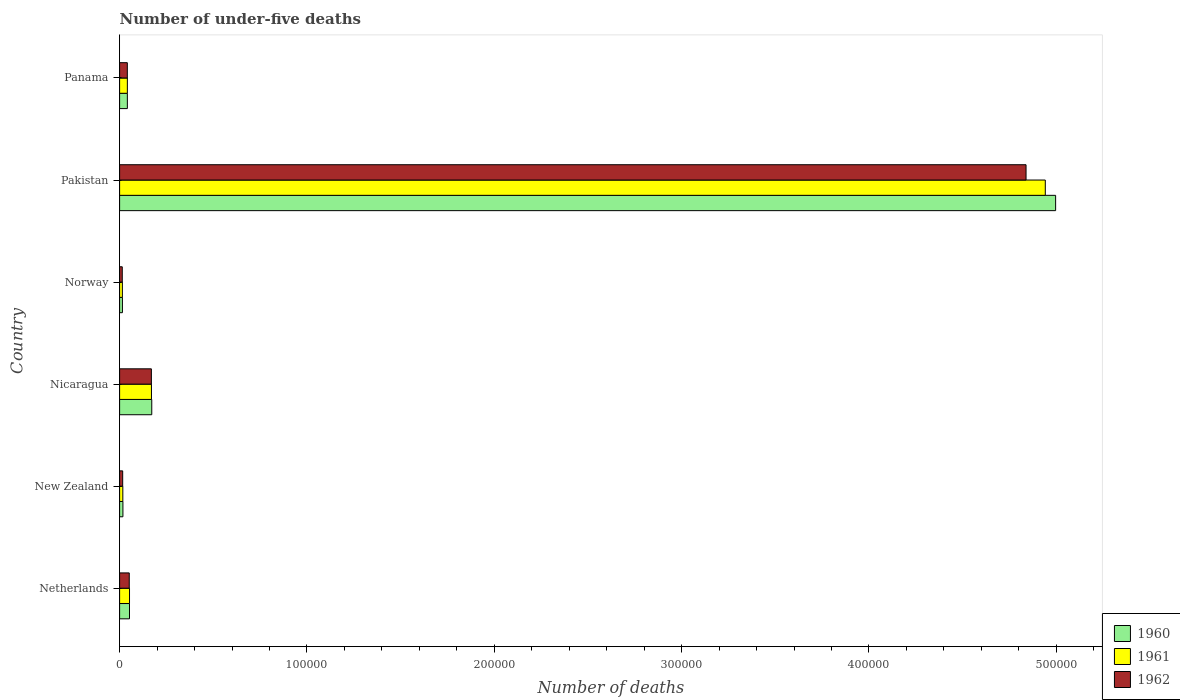Are the number of bars per tick equal to the number of legend labels?
Ensure brevity in your answer.  Yes. Are the number of bars on each tick of the Y-axis equal?
Provide a succinct answer. Yes. How many bars are there on the 2nd tick from the top?
Give a very brief answer. 3. How many bars are there on the 4th tick from the bottom?
Offer a very short reply. 3. In how many cases, is the number of bars for a given country not equal to the number of legend labels?
Make the answer very short. 0. What is the number of under-five deaths in 1962 in New Zealand?
Your answer should be very brief. 1649. Across all countries, what is the maximum number of under-five deaths in 1962?
Keep it short and to the point. 4.84e+05. Across all countries, what is the minimum number of under-five deaths in 1961?
Offer a very short reply. 1480. In which country was the number of under-five deaths in 1960 maximum?
Your answer should be very brief. Pakistan. What is the total number of under-five deaths in 1962 in the graph?
Make the answer very short. 5.13e+05. What is the difference between the number of under-five deaths in 1960 in Netherlands and that in Norway?
Offer a very short reply. 3778. What is the difference between the number of under-five deaths in 1961 in Netherlands and the number of under-five deaths in 1962 in Norway?
Keep it short and to the point. 3866. What is the average number of under-five deaths in 1962 per country?
Give a very brief answer. 8.55e+04. In how many countries, is the number of under-five deaths in 1960 greater than 300000 ?
Keep it short and to the point. 1. What is the ratio of the number of under-five deaths in 1961 in Netherlands to that in Pakistan?
Offer a terse response. 0.01. Is the number of under-five deaths in 1960 in New Zealand less than that in Panama?
Your answer should be compact. Yes. Is the difference between the number of under-five deaths in 1960 in Netherlands and New Zealand greater than the difference between the number of under-five deaths in 1961 in Netherlands and New Zealand?
Offer a terse response. No. What is the difference between the highest and the second highest number of under-five deaths in 1961?
Your answer should be very brief. 4.77e+05. What is the difference between the highest and the lowest number of under-five deaths in 1960?
Your answer should be very brief. 4.98e+05. Is it the case that in every country, the sum of the number of under-five deaths in 1961 and number of under-five deaths in 1962 is greater than the number of under-five deaths in 1960?
Offer a terse response. Yes. How many countries are there in the graph?
Keep it short and to the point. 6. Does the graph contain grids?
Your response must be concise. No. Where does the legend appear in the graph?
Your answer should be very brief. Bottom right. How many legend labels are there?
Offer a terse response. 3. How are the legend labels stacked?
Give a very brief answer. Vertical. What is the title of the graph?
Your answer should be very brief. Number of under-five deaths. What is the label or title of the X-axis?
Ensure brevity in your answer.  Number of deaths. What is the Number of deaths in 1960 in Netherlands?
Provide a succinct answer. 5281. What is the Number of deaths in 1961 in Netherlands?
Your response must be concise. 5288. What is the Number of deaths of 1962 in Netherlands?
Your response must be concise. 5152. What is the Number of deaths in 1960 in New Zealand?
Ensure brevity in your answer.  1768. What is the Number of deaths in 1961 in New Zealand?
Offer a very short reply. 1719. What is the Number of deaths in 1962 in New Zealand?
Provide a short and direct response. 1649. What is the Number of deaths of 1960 in Nicaragua?
Ensure brevity in your answer.  1.72e+04. What is the Number of deaths of 1961 in Nicaragua?
Keep it short and to the point. 1.70e+04. What is the Number of deaths of 1962 in Nicaragua?
Your response must be concise. 1.70e+04. What is the Number of deaths in 1960 in Norway?
Offer a terse response. 1503. What is the Number of deaths in 1961 in Norway?
Give a very brief answer. 1480. What is the Number of deaths in 1962 in Norway?
Make the answer very short. 1422. What is the Number of deaths of 1960 in Pakistan?
Provide a short and direct response. 5.00e+05. What is the Number of deaths in 1961 in Pakistan?
Your response must be concise. 4.94e+05. What is the Number of deaths in 1962 in Pakistan?
Give a very brief answer. 4.84e+05. What is the Number of deaths of 1960 in Panama?
Offer a terse response. 4142. What is the Number of deaths of 1961 in Panama?
Offer a very short reply. 4139. What is the Number of deaths in 1962 in Panama?
Your answer should be very brief. 4122. Across all countries, what is the maximum Number of deaths in 1960?
Provide a succinct answer. 5.00e+05. Across all countries, what is the maximum Number of deaths in 1961?
Ensure brevity in your answer.  4.94e+05. Across all countries, what is the maximum Number of deaths of 1962?
Ensure brevity in your answer.  4.84e+05. Across all countries, what is the minimum Number of deaths of 1960?
Your answer should be compact. 1503. Across all countries, what is the minimum Number of deaths of 1961?
Your response must be concise. 1480. Across all countries, what is the minimum Number of deaths of 1962?
Ensure brevity in your answer.  1422. What is the total Number of deaths in 1960 in the graph?
Your response must be concise. 5.30e+05. What is the total Number of deaths of 1961 in the graph?
Your answer should be very brief. 5.24e+05. What is the total Number of deaths of 1962 in the graph?
Ensure brevity in your answer.  5.13e+05. What is the difference between the Number of deaths in 1960 in Netherlands and that in New Zealand?
Ensure brevity in your answer.  3513. What is the difference between the Number of deaths in 1961 in Netherlands and that in New Zealand?
Offer a terse response. 3569. What is the difference between the Number of deaths of 1962 in Netherlands and that in New Zealand?
Provide a short and direct response. 3503. What is the difference between the Number of deaths of 1960 in Netherlands and that in Nicaragua?
Offer a very short reply. -1.19e+04. What is the difference between the Number of deaths in 1961 in Netherlands and that in Nicaragua?
Offer a terse response. -1.17e+04. What is the difference between the Number of deaths in 1962 in Netherlands and that in Nicaragua?
Offer a very short reply. -1.18e+04. What is the difference between the Number of deaths of 1960 in Netherlands and that in Norway?
Your answer should be compact. 3778. What is the difference between the Number of deaths of 1961 in Netherlands and that in Norway?
Make the answer very short. 3808. What is the difference between the Number of deaths of 1962 in Netherlands and that in Norway?
Provide a short and direct response. 3730. What is the difference between the Number of deaths of 1960 in Netherlands and that in Pakistan?
Ensure brevity in your answer.  -4.94e+05. What is the difference between the Number of deaths of 1961 in Netherlands and that in Pakistan?
Give a very brief answer. -4.89e+05. What is the difference between the Number of deaths of 1962 in Netherlands and that in Pakistan?
Your answer should be very brief. -4.79e+05. What is the difference between the Number of deaths of 1960 in Netherlands and that in Panama?
Ensure brevity in your answer.  1139. What is the difference between the Number of deaths in 1961 in Netherlands and that in Panama?
Your answer should be very brief. 1149. What is the difference between the Number of deaths in 1962 in Netherlands and that in Panama?
Offer a very short reply. 1030. What is the difference between the Number of deaths in 1960 in New Zealand and that in Nicaragua?
Provide a succinct answer. -1.54e+04. What is the difference between the Number of deaths of 1961 in New Zealand and that in Nicaragua?
Your answer should be compact. -1.53e+04. What is the difference between the Number of deaths in 1962 in New Zealand and that in Nicaragua?
Provide a succinct answer. -1.53e+04. What is the difference between the Number of deaths in 1960 in New Zealand and that in Norway?
Provide a short and direct response. 265. What is the difference between the Number of deaths of 1961 in New Zealand and that in Norway?
Ensure brevity in your answer.  239. What is the difference between the Number of deaths in 1962 in New Zealand and that in Norway?
Give a very brief answer. 227. What is the difference between the Number of deaths of 1960 in New Zealand and that in Pakistan?
Offer a very short reply. -4.98e+05. What is the difference between the Number of deaths in 1961 in New Zealand and that in Pakistan?
Offer a very short reply. -4.92e+05. What is the difference between the Number of deaths of 1962 in New Zealand and that in Pakistan?
Your answer should be compact. -4.82e+05. What is the difference between the Number of deaths of 1960 in New Zealand and that in Panama?
Offer a very short reply. -2374. What is the difference between the Number of deaths of 1961 in New Zealand and that in Panama?
Provide a succinct answer. -2420. What is the difference between the Number of deaths of 1962 in New Zealand and that in Panama?
Offer a terse response. -2473. What is the difference between the Number of deaths in 1960 in Nicaragua and that in Norway?
Give a very brief answer. 1.57e+04. What is the difference between the Number of deaths in 1961 in Nicaragua and that in Norway?
Make the answer very short. 1.55e+04. What is the difference between the Number of deaths of 1962 in Nicaragua and that in Norway?
Make the answer very short. 1.55e+04. What is the difference between the Number of deaths of 1960 in Nicaragua and that in Pakistan?
Your response must be concise. -4.82e+05. What is the difference between the Number of deaths in 1961 in Nicaragua and that in Pakistan?
Your answer should be compact. -4.77e+05. What is the difference between the Number of deaths in 1962 in Nicaragua and that in Pakistan?
Your response must be concise. -4.67e+05. What is the difference between the Number of deaths in 1960 in Nicaragua and that in Panama?
Your answer should be compact. 1.30e+04. What is the difference between the Number of deaths in 1961 in Nicaragua and that in Panama?
Make the answer very short. 1.29e+04. What is the difference between the Number of deaths in 1962 in Nicaragua and that in Panama?
Make the answer very short. 1.28e+04. What is the difference between the Number of deaths of 1960 in Norway and that in Pakistan?
Provide a short and direct response. -4.98e+05. What is the difference between the Number of deaths in 1961 in Norway and that in Pakistan?
Your answer should be compact. -4.93e+05. What is the difference between the Number of deaths of 1962 in Norway and that in Pakistan?
Your answer should be very brief. -4.82e+05. What is the difference between the Number of deaths of 1960 in Norway and that in Panama?
Offer a very short reply. -2639. What is the difference between the Number of deaths in 1961 in Norway and that in Panama?
Offer a very short reply. -2659. What is the difference between the Number of deaths of 1962 in Norway and that in Panama?
Make the answer very short. -2700. What is the difference between the Number of deaths of 1960 in Pakistan and that in Panama?
Make the answer very short. 4.96e+05. What is the difference between the Number of deaths in 1961 in Pakistan and that in Panama?
Your answer should be compact. 4.90e+05. What is the difference between the Number of deaths in 1962 in Pakistan and that in Panama?
Give a very brief answer. 4.80e+05. What is the difference between the Number of deaths in 1960 in Netherlands and the Number of deaths in 1961 in New Zealand?
Your answer should be very brief. 3562. What is the difference between the Number of deaths in 1960 in Netherlands and the Number of deaths in 1962 in New Zealand?
Your response must be concise. 3632. What is the difference between the Number of deaths of 1961 in Netherlands and the Number of deaths of 1962 in New Zealand?
Give a very brief answer. 3639. What is the difference between the Number of deaths in 1960 in Netherlands and the Number of deaths in 1961 in Nicaragua?
Give a very brief answer. -1.17e+04. What is the difference between the Number of deaths in 1960 in Netherlands and the Number of deaths in 1962 in Nicaragua?
Provide a short and direct response. -1.17e+04. What is the difference between the Number of deaths in 1961 in Netherlands and the Number of deaths in 1962 in Nicaragua?
Offer a terse response. -1.17e+04. What is the difference between the Number of deaths in 1960 in Netherlands and the Number of deaths in 1961 in Norway?
Your response must be concise. 3801. What is the difference between the Number of deaths of 1960 in Netherlands and the Number of deaths of 1962 in Norway?
Keep it short and to the point. 3859. What is the difference between the Number of deaths in 1961 in Netherlands and the Number of deaths in 1962 in Norway?
Provide a succinct answer. 3866. What is the difference between the Number of deaths of 1960 in Netherlands and the Number of deaths of 1961 in Pakistan?
Your answer should be compact. -4.89e+05. What is the difference between the Number of deaths of 1960 in Netherlands and the Number of deaths of 1962 in Pakistan?
Keep it short and to the point. -4.79e+05. What is the difference between the Number of deaths in 1961 in Netherlands and the Number of deaths in 1962 in Pakistan?
Your answer should be compact. -4.79e+05. What is the difference between the Number of deaths of 1960 in Netherlands and the Number of deaths of 1961 in Panama?
Provide a short and direct response. 1142. What is the difference between the Number of deaths of 1960 in Netherlands and the Number of deaths of 1962 in Panama?
Keep it short and to the point. 1159. What is the difference between the Number of deaths in 1961 in Netherlands and the Number of deaths in 1962 in Panama?
Offer a very short reply. 1166. What is the difference between the Number of deaths of 1960 in New Zealand and the Number of deaths of 1961 in Nicaragua?
Keep it short and to the point. -1.52e+04. What is the difference between the Number of deaths of 1960 in New Zealand and the Number of deaths of 1962 in Nicaragua?
Provide a succinct answer. -1.52e+04. What is the difference between the Number of deaths in 1961 in New Zealand and the Number of deaths in 1962 in Nicaragua?
Your answer should be compact. -1.52e+04. What is the difference between the Number of deaths of 1960 in New Zealand and the Number of deaths of 1961 in Norway?
Provide a succinct answer. 288. What is the difference between the Number of deaths of 1960 in New Zealand and the Number of deaths of 1962 in Norway?
Your answer should be very brief. 346. What is the difference between the Number of deaths in 1961 in New Zealand and the Number of deaths in 1962 in Norway?
Give a very brief answer. 297. What is the difference between the Number of deaths of 1960 in New Zealand and the Number of deaths of 1961 in Pakistan?
Your response must be concise. -4.92e+05. What is the difference between the Number of deaths of 1960 in New Zealand and the Number of deaths of 1962 in Pakistan?
Make the answer very short. -4.82e+05. What is the difference between the Number of deaths in 1961 in New Zealand and the Number of deaths in 1962 in Pakistan?
Keep it short and to the point. -4.82e+05. What is the difference between the Number of deaths in 1960 in New Zealand and the Number of deaths in 1961 in Panama?
Offer a terse response. -2371. What is the difference between the Number of deaths in 1960 in New Zealand and the Number of deaths in 1962 in Panama?
Make the answer very short. -2354. What is the difference between the Number of deaths of 1961 in New Zealand and the Number of deaths of 1962 in Panama?
Provide a short and direct response. -2403. What is the difference between the Number of deaths in 1960 in Nicaragua and the Number of deaths in 1961 in Norway?
Your answer should be compact. 1.57e+04. What is the difference between the Number of deaths in 1960 in Nicaragua and the Number of deaths in 1962 in Norway?
Offer a very short reply. 1.57e+04. What is the difference between the Number of deaths in 1961 in Nicaragua and the Number of deaths in 1962 in Norway?
Your answer should be very brief. 1.56e+04. What is the difference between the Number of deaths of 1960 in Nicaragua and the Number of deaths of 1961 in Pakistan?
Make the answer very short. -4.77e+05. What is the difference between the Number of deaths in 1960 in Nicaragua and the Number of deaths in 1962 in Pakistan?
Your answer should be very brief. -4.67e+05. What is the difference between the Number of deaths of 1961 in Nicaragua and the Number of deaths of 1962 in Pakistan?
Offer a very short reply. -4.67e+05. What is the difference between the Number of deaths in 1960 in Nicaragua and the Number of deaths in 1961 in Panama?
Your answer should be very brief. 1.30e+04. What is the difference between the Number of deaths in 1960 in Nicaragua and the Number of deaths in 1962 in Panama?
Provide a short and direct response. 1.30e+04. What is the difference between the Number of deaths of 1961 in Nicaragua and the Number of deaths of 1962 in Panama?
Give a very brief answer. 1.29e+04. What is the difference between the Number of deaths in 1960 in Norway and the Number of deaths in 1961 in Pakistan?
Offer a terse response. -4.93e+05. What is the difference between the Number of deaths of 1960 in Norway and the Number of deaths of 1962 in Pakistan?
Your response must be concise. -4.82e+05. What is the difference between the Number of deaths of 1961 in Norway and the Number of deaths of 1962 in Pakistan?
Provide a succinct answer. -4.82e+05. What is the difference between the Number of deaths in 1960 in Norway and the Number of deaths in 1961 in Panama?
Offer a very short reply. -2636. What is the difference between the Number of deaths of 1960 in Norway and the Number of deaths of 1962 in Panama?
Give a very brief answer. -2619. What is the difference between the Number of deaths of 1961 in Norway and the Number of deaths of 1962 in Panama?
Offer a very short reply. -2642. What is the difference between the Number of deaths in 1960 in Pakistan and the Number of deaths in 1961 in Panama?
Offer a terse response. 4.96e+05. What is the difference between the Number of deaths of 1960 in Pakistan and the Number of deaths of 1962 in Panama?
Make the answer very short. 4.96e+05. What is the difference between the Number of deaths of 1961 in Pakistan and the Number of deaths of 1962 in Panama?
Ensure brevity in your answer.  4.90e+05. What is the average Number of deaths of 1960 per country?
Keep it short and to the point. 8.83e+04. What is the average Number of deaths of 1961 per country?
Provide a short and direct response. 8.73e+04. What is the average Number of deaths in 1962 per country?
Keep it short and to the point. 8.55e+04. What is the difference between the Number of deaths in 1960 and Number of deaths in 1961 in Netherlands?
Provide a short and direct response. -7. What is the difference between the Number of deaths of 1960 and Number of deaths of 1962 in Netherlands?
Your answer should be very brief. 129. What is the difference between the Number of deaths of 1961 and Number of deaths of 1962 in Netherlands?
Make the answer very short. 136. What is the difference between the Number of deaths in 1960 and Number of deaths in 1961 in New Zealand?
Your answer should be compact. 49. What is the difference between the Number of deaths in 1960 and Number of deaths in 1962 in New Zealand?
Give a very brief answer. 119. What is the difference between the Number of deaths in 1961 and Number of deaths in 1962 in New Zealand?
Offer a terse response. 70. What is the difference between the Number of deaths in 1960 and Number of deaths in 1961 in Nicaragua?
Your response must be concise. 167. What is the difference between the Number of deaths of 1960 and Number of deaths of 1962 in Nicaragua?
Offer a terse response. 207. What is the difference between the Number of deaths in 1961 and Number of deaths in 1962 in Nicaragua?
Offer a terse response. 40. What is the difference between the Number of deaths in 1960 and Number of deaths in 1961 in Norway?
Your response must be concise. 23. What is the difference between the Number of deaths in 1960 and Number of deaths in 1961 in Pakistan?
Offer a terse response. 5515. What is the difference between the Number of deaths in 1960 and Number of deaths in 1962 in Pakistan?
Provide a short and direct response. 1.58e+04. What is the difference between the Number of deaths in 1961 and Number of deaths in 1962 in Pakistan?
Ensure brevity in your answer.  1.03e+04. What is the difference between the Number of deaths in 1961 and Number of deaths in 1962 in Panama?
Provide a succinct answer. 17. What is the ratio of the Number of deaths of 1960 in Netherlands to that in New Zealand?
Your answer should be compact. 2.99. What is the ratio of the Number of deaths in 1961 in Netherlands to that in New Zealand?
Your answer should be very brief. 3.08. What is the ratio of the Number of deaths of 1962 in Netherlands to that in New Zealand?
Your answer should be very brief. 3.12. What is the ratio of the Number of deaths in 1960 in Netherlands to that in Nicaragua?
Your answer should be compact. 0.31. What is the ratio of the Number of deaths of 1961 in Netherlands to that in Nicaragua?
Give a very brief answer. 0.31. What is the ratio of the Number of deaths in 1962 in Netherlands to that in Nicaragua?
Give a very brief answer. 0.3. What is the ratio of the Number of deaths of 1960 in Netherlands to that in Norway?
Ensure brevity in your answer.  3.51. What is the ratio of the Number of deaths of 1961 in Netherlands to that in Norway?
Your answer should be compact. 3.57. What is the ratio of the Number of deaths of 1962 in Netherlands to that in Norway?
Offer a terse response. 3.62. What is the ratio of the Number of deaths in 1960 in Netherlands to that in Pakistan?
Keep it short and to the point. 0.01. What is the ratio of the Number of deaths of 1961 in Netherlands to that in Pakistan?
Your response must be concise. 0.01. What is the ratio of the Number of deaths in 1962 in Netherlands to that in Pakistan?
Your response must be concise. 0.01. What is the ratio of the Number of deaths of 1960 in Netherlands to that in Panama?
Your response must be concise. 1.27. What is the ratio of the Number of deaths of 1961 in Netherlands to that in Panama?
Make the answer very short. 1.28. What is the ratio of the Number of deaths in 1962 in Netherlands to that in Panama?
Offer a terse response. 1.25. What is the ratio of the Number of deaths in 1960 in New Zealand to that in Nicaragua?
Offer a very short reply. 0.1. What is the ratio of the Number of deaths of 1961 in New Zealand to that in Nicaragua?
Offer a terse response. 0.1. What is the ratio of the Number of deaths of 1962 in New Zealand to that in Nicaragua?
Offer a terse response. 0.1. What is the ratio of the Number of deaths of 1960 in New Zealand to that in Norway?
Keep it short and to the point. 1.18. What is the ratio of the Number of deaths in 1961 in New Zealand to that in Norway?
Provide a succinct answer. 1.16. What is the ratio of the Number of deaths of 1962 in New Zealand to that in Norway?
Keep it short and to the point. 1.16. What is the ratio of the Number of deaths in 1960 in New Zealand to that in Pakistan?
Your answer should be compact. 0. What is the ratio of the Number of deaths of 1961 in New Zealand to that in Pakistan?
Keep it short and to the point. 0. What is the ratio of the Number of deaths of 1962 in New Zealand to that in Pakistan?
Make the answer very short. 0. What is the ratio of the Number of deaths of 1960 in New Zealand to that in Panama?
Provide a short and direct response. 0.43. What is the ratio of the Number of deaths in 1961 in New Zealand to that in Panama?
Your answer should be very brief. 0.42. What is the ratio of the Number of deaths of 1962 in New Zealand to that in Panama?
Keep it short and to the point. 0.4. What is the ratio of the Number of deaths in 1960 in Nicaragua to that in Norway?
Your answer should be very brief. 11.42. What is the ratio of the Number of deaths of 1961 in Nicaragua to that in Norway?
Give a very brief answer. 11.49. What is the ratio of the Number of deaths of 1962 in Nicaragua to that in Norway?
Ensure brevity in your answer.  11.93. What is the ratio of the Number of deaths in 1960 in Nicaragua to that in Pakistan?
Make the answer very short. 0.03. What is the ratio of the Number of deaths of 1961 in Nicaragua to that in Pakistan?
Offer a terse response. 0.03. What is the ratio of the Number of deaths in 1962 in Nicaragua to that in Pakistan?
Offer a very short reply. 0.04. What is the ratio of the Number of deaths in 1960 in Nicaragua to that in Panama?
Offer a very short reply. 4.15. What is the ratio of the Number of deaths in 1961 in Nicaragua to that in Panama?
Your response must be concise. 4.11. What is the ratio of the Number of deaths in 1962 in Nicaragua to that in Panama?
Offer a very short reply. 4.12. What is the ratio of the Number of deaths in 1960 in Norway to that in Pakistan?
Provide a short and direct response. 0. What is the ratio of the Number of deaths of 1961 in Norway to that in Pakistan?
Provide a succinct answer. 0. What is the ratio of the Number of deaths of 1962 in Norway to that in Pakistan?
Provide a short and direct response. 0. What is the ratio of the Number of deaths of 1960 in Norway to that in Panama?
Give a very brief answer. 0.36. What is the ratio of the Number of deaths of 1961 in Norway to that in Panama?
Make the answer very short. 0.36. What is the ratio of the Number of deaths of 1962 in Norway to that in Panama?
Offer a very short reply. 0.34. What is the ratio of the Number of deaths of 1960 in Pakistan to that in Panama?
Make the answer very short. 120.63. What is the ratio of the Number of deaths of 1961 in Pakistan to that in Panama?
Your answer should be compact. 119.38. What is the ratio of the Number of deaths in 1962 in Pakistan to that in Panama?
Give a very brief answer. 117.38. What is the difference between the highest and the second highest Number of deaths of 1960?
Your answer should be very brief. 4.82e+05. What is the difference between the highest and the second highest Number of deaths in 1961?
Give a very brief answer. 4.77e+05. What is the difference between the highest and the second highest Number of deaths in 1962?
Give a very brief answer. 4.67e+05. What is the difference between the highest and the lowest Number of deaths of 1960?
Keep it short and to the point. 4.98e+05. What is the difference between the highest and the lowest Number of deaths in 1961?
Keep it short and to the point. 4.93e+05. What is the difference between the highest and the lowest Number of deaths in 1962?
Your answer should be very brief. 4.82e+05. 